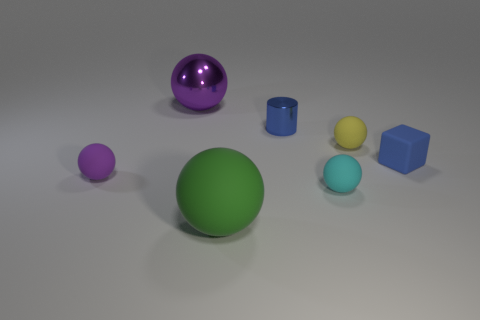Subtract all purple spheres. How many were subtracted if there are1purple spheres left? 1 Subtract all cyan balls. How many balls are left? 4 Subtract all large green rubber spheres. How many spheres are left? 4 Subtract all brown spheres. Subtract all yellow cylinders. How many spheres are left? 5 Add 1 blue rubber cubes. How many objects exist? 8 Subtract all cubes. How many objects are left? 6 Subtract 0 gray blocks. How many objects are left? 7 Subtract all green matte objects. Subtract all tiny shiny objects. How many objects are left? 5 Add 7 small yellow objects. How many small yellow objects are left? 8 Add 3 small objects. How many small objects exist? 8 